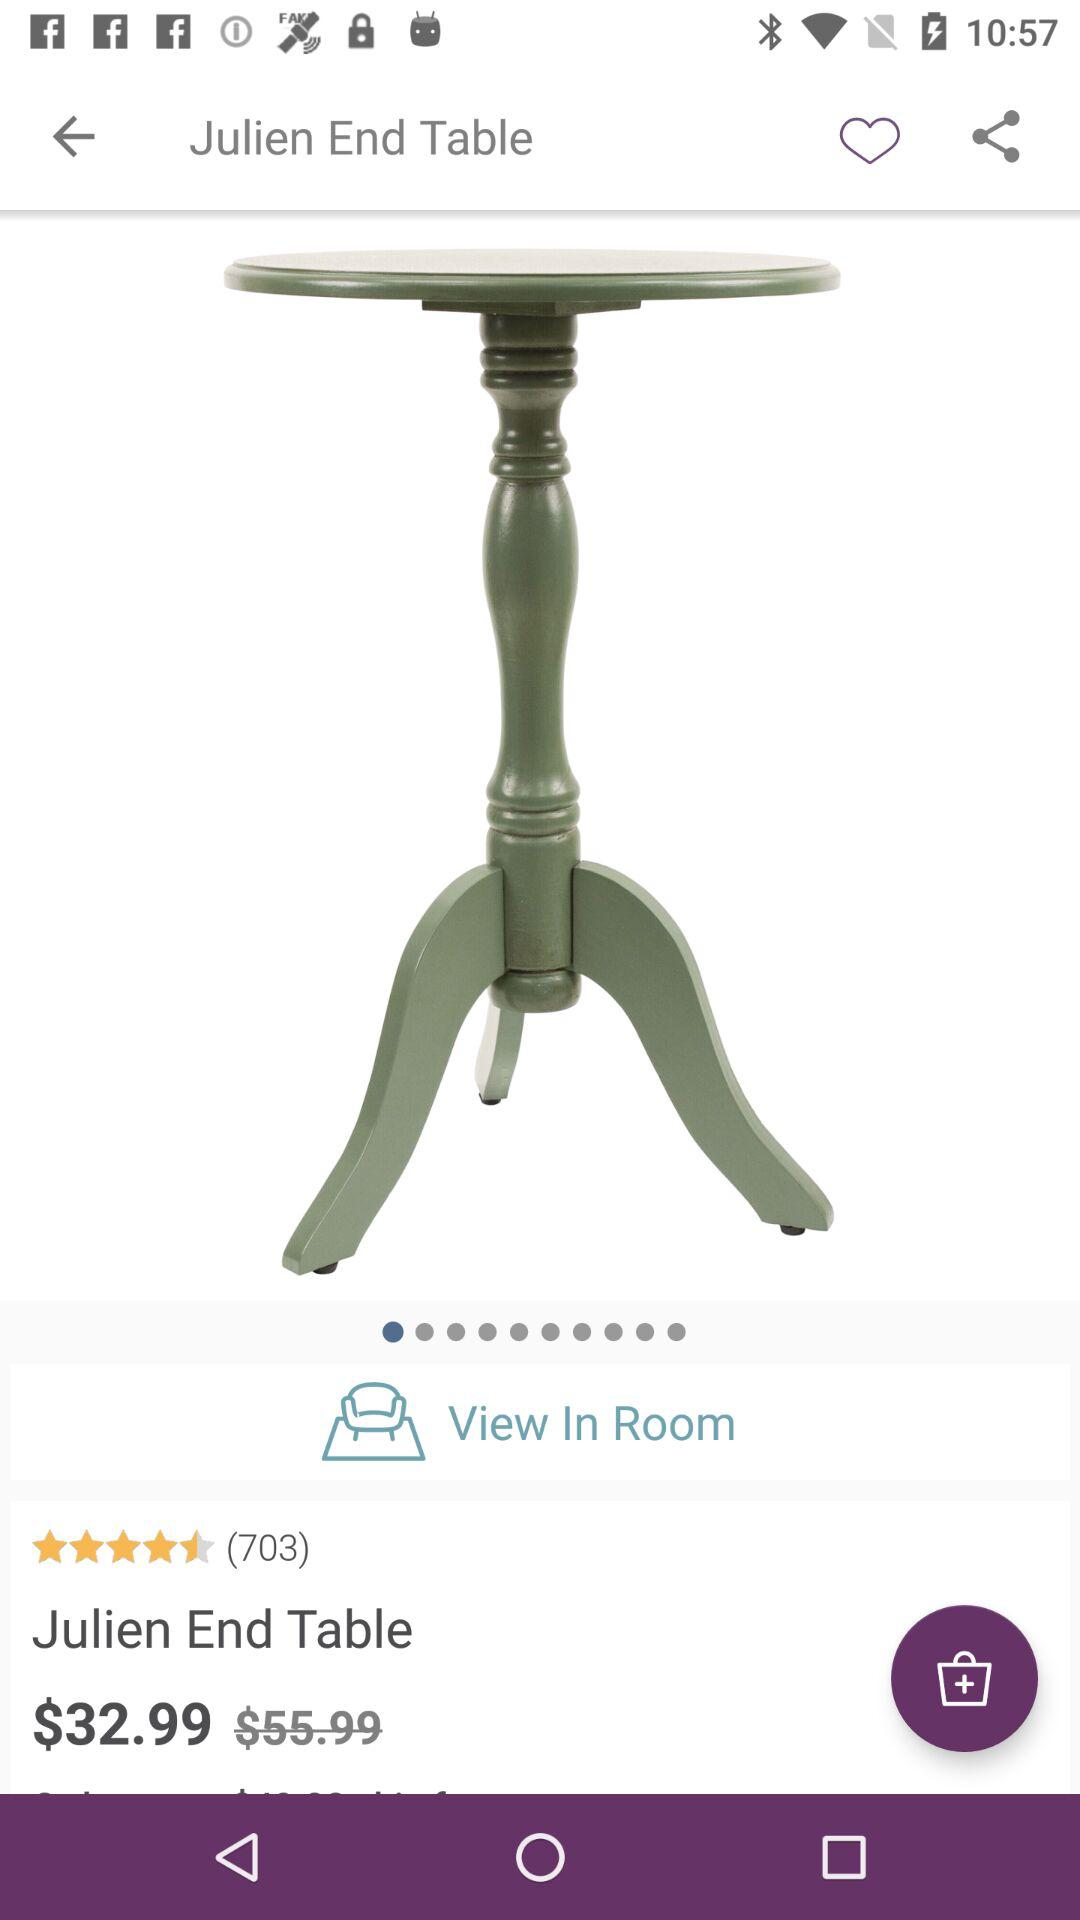How much cheaper is the product than the original price?
Answer the question using a single word or phrase. $23.00 